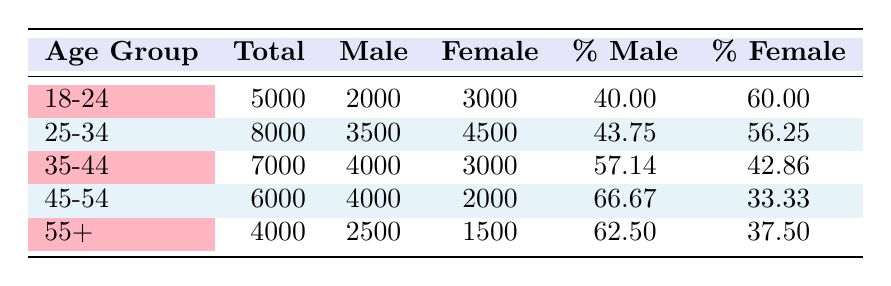What is the total number of union members in the age group 45-54? The table directly states the total number of members in the age group 45-54 as 6000.
Answer: 6000 What percentage of union members aged 18-24 are female? According to the table, the percentage of female members in the 18-24 age group is given as 60.00%.
Answer: 60.00% Which age group has the highest percentage of male union members? The 45-54 age group has the highest percentage of male members at 66.67%. This is compared with other age groups in the table.
Answer: 45-54 How many more female members are there in the 25-34 age group compared to the 35-44 age group? The number of female members in the 25-34 age group is 4500, while in the 35-44 age group it is 3000. Thus, 4500 - 3000 = 1500 more female members in the 25-34 age group.
Answer: 1500 Is the number of male members in the age group 55+ greater than the number of female members in the same group? The table shows there are 2500 male members and 1500 female members in the 55+ age group. Therefore, 2500 > 1500, making the statement true.
Answer: Yes What is the average percentage of female members across all age groups? The percentages of female members for each age group are: 60.00, 56.25, 42.86, 33.33, and 37.50. Adding these gives a total of 229.94. Dividing this by 5 gives an average percentage of 45.988, which rounds to approximately 46.00%.
Answer: 46.00 Which age group has the lowest total membership? By inspecting the total member numbers, the 55+ age group has the lowest total at 4000.
Answer: 55+ Are there more male members aged 25-34 than aged 35-44? The table states there are 3500 male members in the 25-34 age group and 4000 in the 35-44 age group. Comparing these values shows that 3500 < 4000, confirming the statement is false.
Answer: No How many total members are there in all age groups combined? Adding all total members from the table gives: 5000 + 8000 + 7000 + 6000 + 4000 = 30000 total members across all age groups.
Answer: 30000 